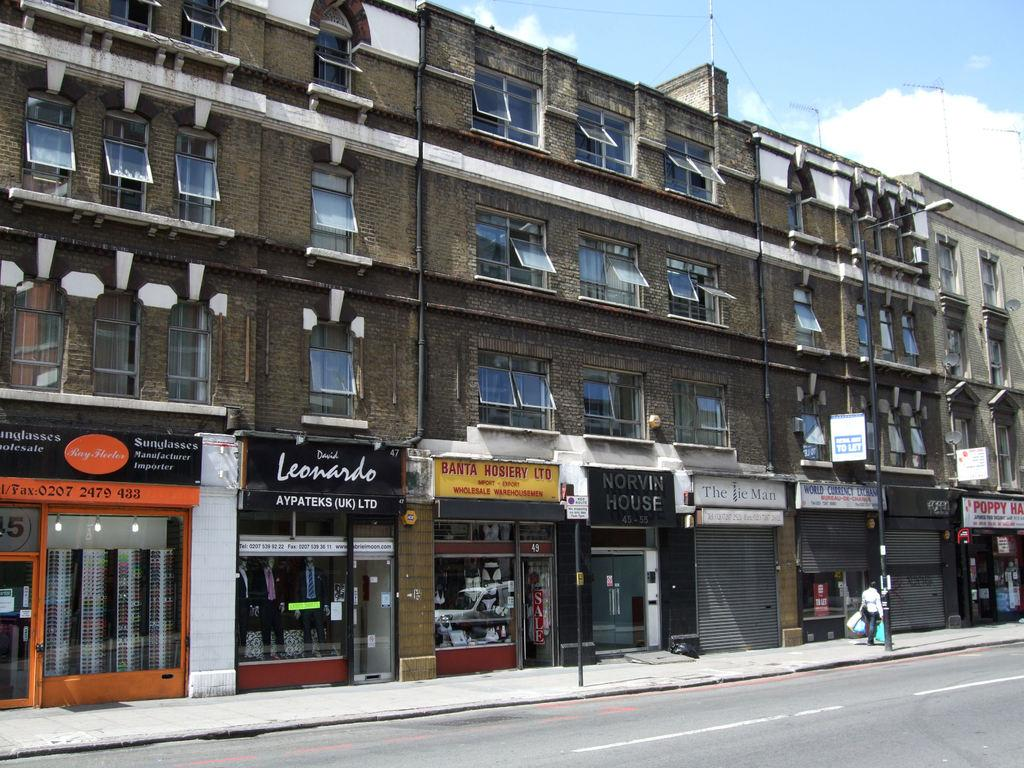What type of structure is present in the image? There is a building in the image. What is located in front of the building? There is a road in front of the building. What can be seen in the sky in the background of the image? There are clouds visible in the sky in the background of the image. What type of branch can be seen hanging from the moon in the image? There is no branch or moon present in the image; it only features a building, a road, and clouds in the sky. 